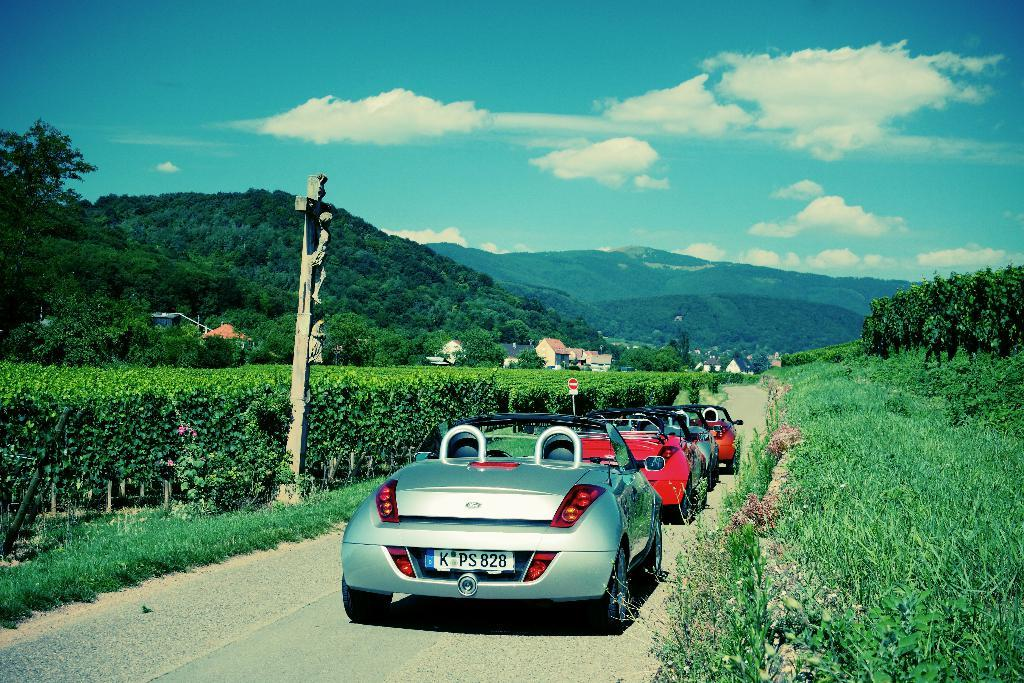What is the main feature of the image? There is a road in the image. What is happening on the road? Cars are moving on the road. What type of vegetation is present on both sides of the road? There is grass and plants on both sides of the road. What can be seen in the background of the image? There are mountains in the background of the image. What is the condition of the sky in the image? The sky is clear in the image. What type of appliance can be seen smashing through the mountains in the image? There is no appliance present in the image, nor is there any indication of something smashing through the mountains. 